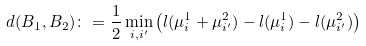<formula> <loc_0><loc_0><loc_500><loc_500>d ( B _ { 1 } , B _ { 2 } ) \colon = \frac { 1 } { 2 } \min _ { i , i ^ { \prime } } \left ( l ( \mu ^ { 1 } _ { i } + \mu ^ { 2 } _ { i ^ { \prime } } ) - l ( \mu ^ { 1 } _ { i } ) - l ( \mu ^ { 2 } _ { i ^ { \prime } } ) \right )</formula> 